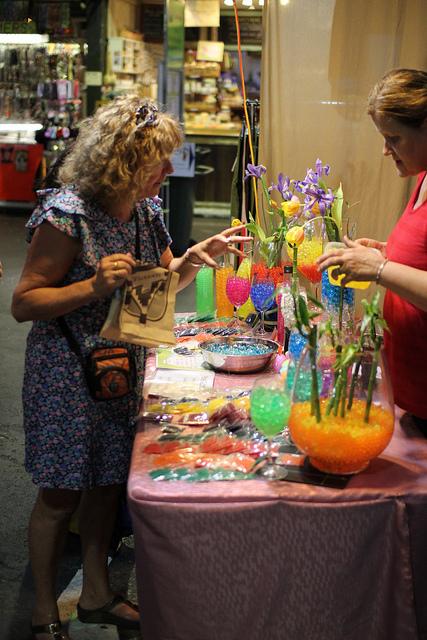Is this a craft fair?
Answer briefly. Yes. What are these ladies doing?
Be succinct. Talking. How many women appear in the picture?
Be succinct. 2. 